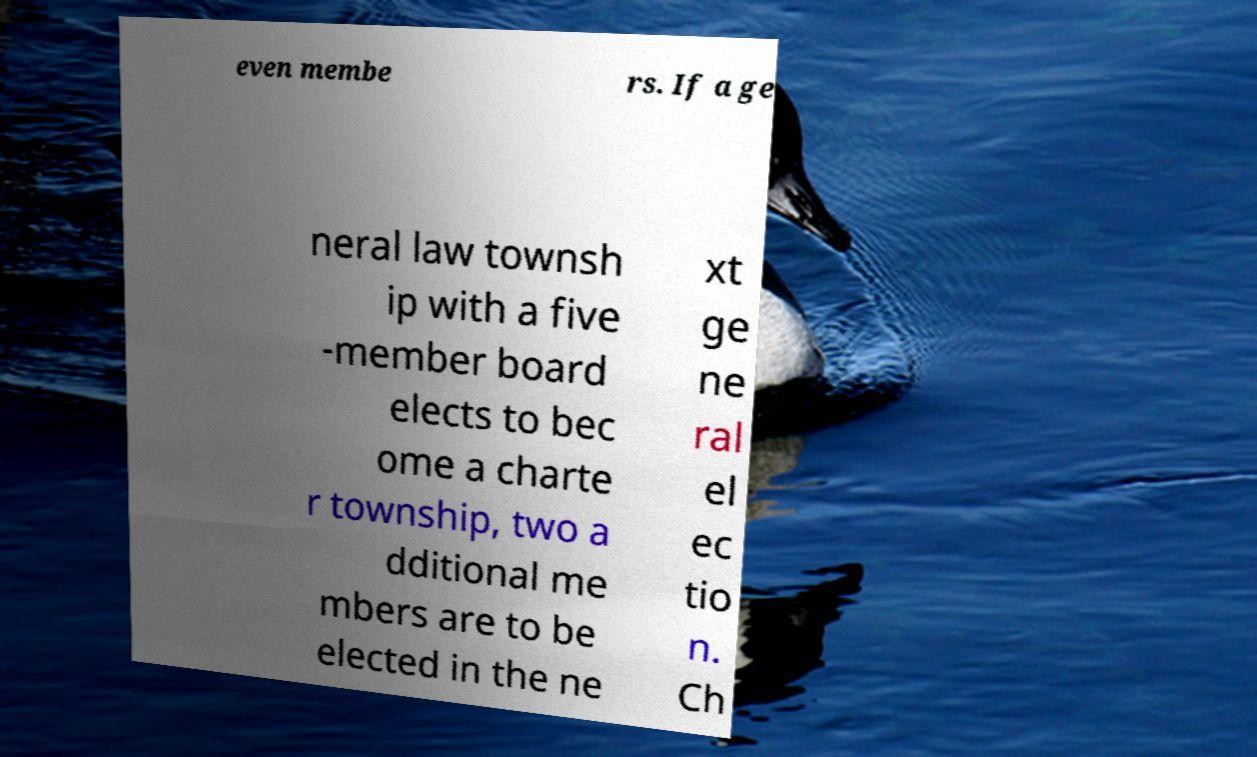Can you accurately transcribe the text from the provided image for me? even membe rs. If a ge neral law townsh ip with a five -member board elects to bec ome a charte r township, two a dditional me mbers are to be elected in the ne xt ge ne ral el ec tio n. Ch 